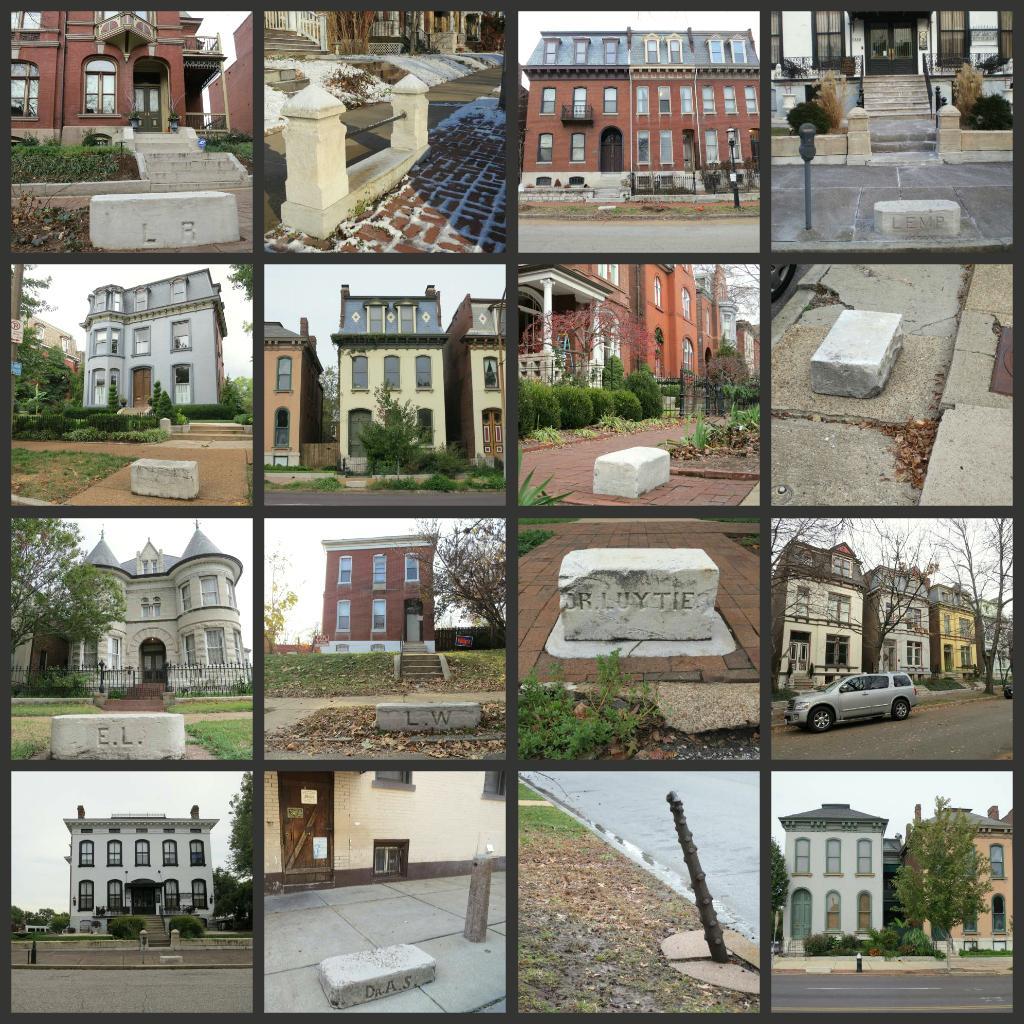Describe this image in one or two sentences. This picture seems to be an edited image with the borders and the collage of images. In these pictures we can see the buildings, ground and we can see the trees, plants and the grass. In the top right corner we can see the stairs and we can see a car seems to be running on the road and we can see the text on the stone, we can see many other objects and in the background we can see the sky and the buildings. 